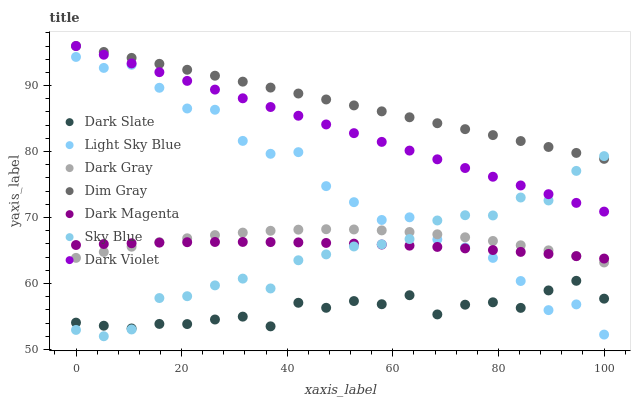Does Dark Slate have the minimum area under the curve?
Answer yes or no. Yes. Does Dim Gray have the maximum area under the curve?
Answer yes or no. Yes. Does Dark Magenta have the minimum area under the curve?
Answer yes or no. No. Does Dark Magenta have the maximum area under the curve?
Answer yes or no. No. Is Dim Gray the smoothest?
Answer yes or no. Yes. Is Light Sky Blue the roughest?
Answer yes or no. Yes. Is Dark Magenta the smoothest?
Answer yes or no. No. Is Dark Magenta the roughest?
Answer yes or no. No. Does Sky Blue have the lowest value?
Answer yes or no. Yes. Does Dark Magenta have the lowest value?
Answer yes or no. No. Does Dark Violet have the highest value?
Answer yes or no. Yes. Does Dark Magenta have the highest value?
Answer yes or no. No. Is Light Sky Blue less than Dim Gray?
Answer yes or no. Yes. Is Dark Gray greater than Dark Slate?
Answer yes or no. Yes. Does Dark Slate intersect Sky Blue?
Answer yes or no. Yes. Is Dark Slate less than Sky Blue?
Answer yes or no. No. Is Dark Slate greater than Sky Blue?
Answer yes or no. No. Does Light Sky Blue intersect Dim Gray?
Answer yes or no. No. 